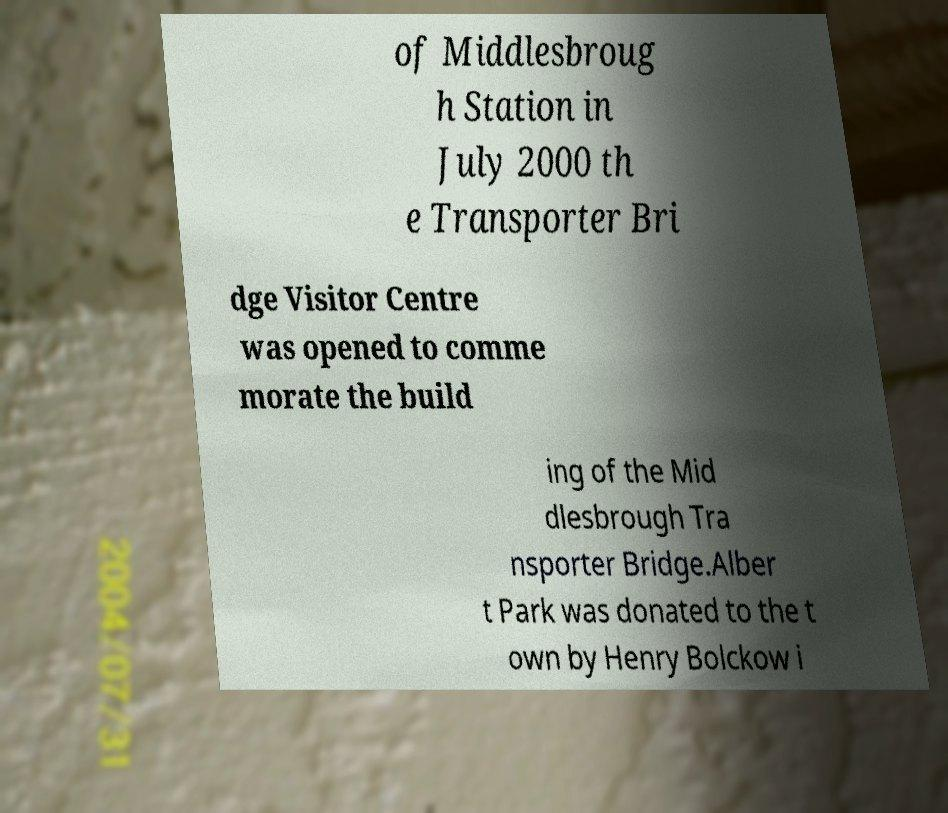Can you read and provide the text displayed in the image?This photo seems to have some interesting text. Can you extract and type it out for me? of Middlesbroug h Station in July 2000 th e Transporter Bri dge Visitor Centre was opened to comme morate the build ing of the Mid dlesbrough Tra nsporter Bridge.Alber t Park was donated to the t own by Henry Bolckow i 